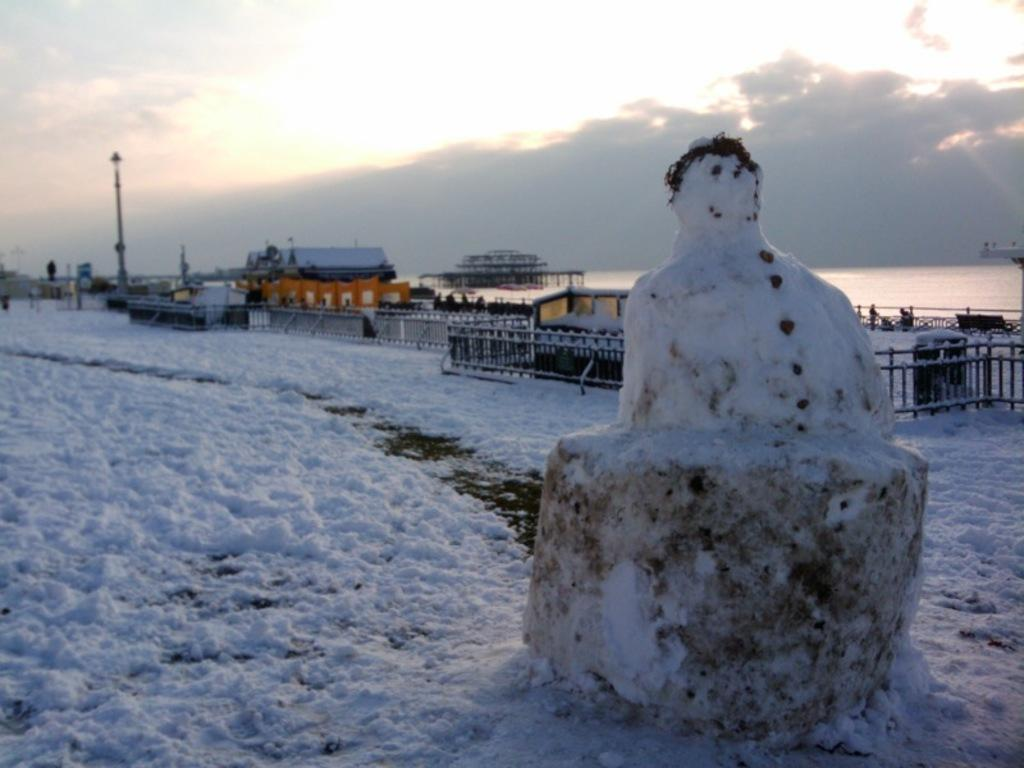What is covering the ground in the image? There is snow on the ground in the image. What can be seen built from the snow in the image? There is a snow figure on the ground. What type of structures are present in the image? There are fences, houses, and buildings in the image. What is the tall, thin object in the image? There is a pole in the image. What else can be seen in the image besides the structures and snow? There are some objects in the image. What is visible in the background of the image? The sky is visible in the background of the image. Can you see a donkey carrying an umbrella in the image? There is no donkey or umbrella present in the image. Is there a trail leading to the buildings in the image? The image does not show a trail leading to the buildings; it only shows the buildings and other elements in the scene. 